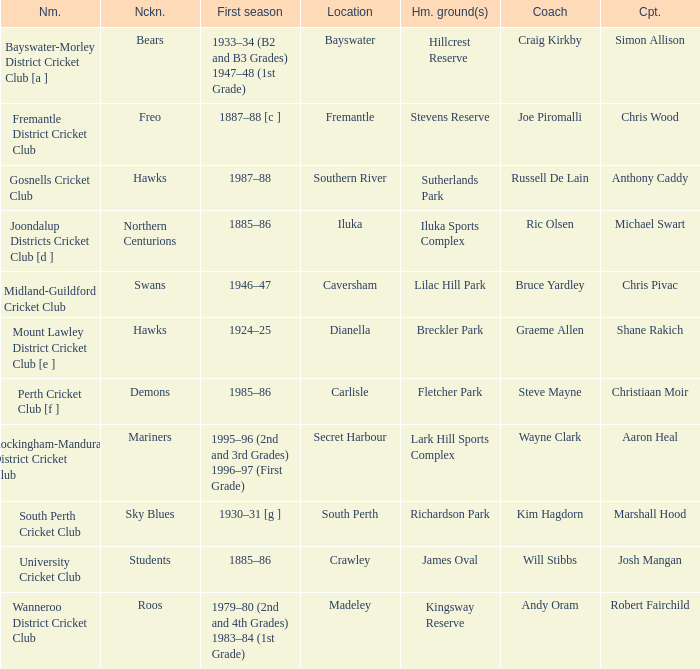What is the code nickname where Steve Mayne is the coach? Demons. 